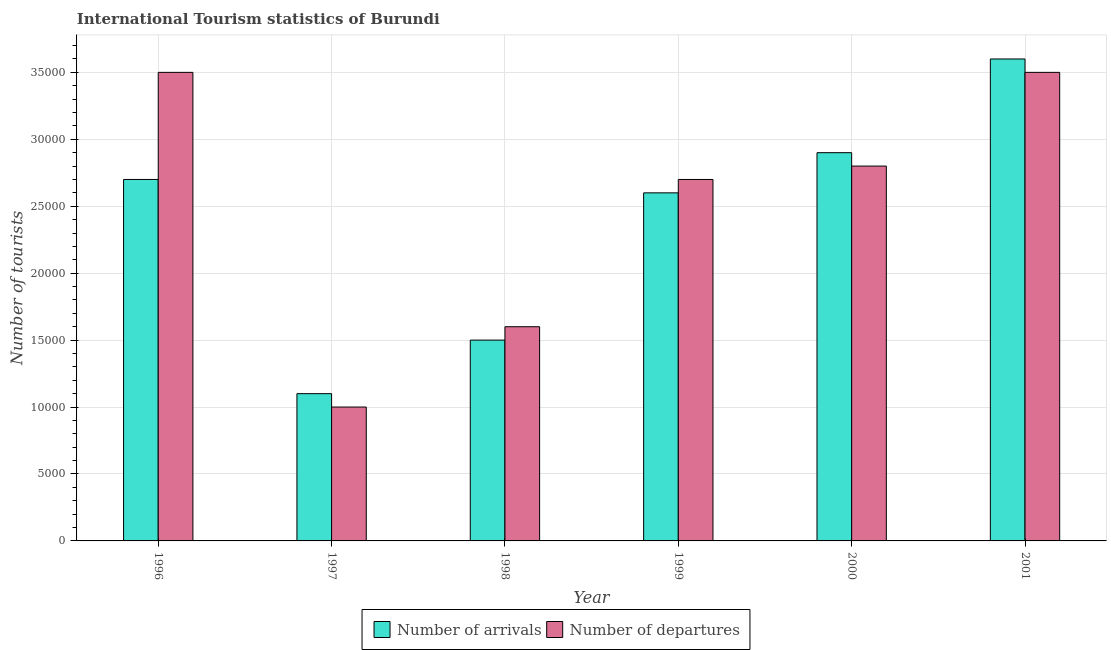How many bars are there on the 6th tick from the right?
Give a very brief answer. 2. What is the label of the 1st group of bars from the left?
Your answer should be very brief. 1996. What is the number of tourist departures in 1998?
Provide a short and direct response. 1.60e+04. Across all years, what is the maximum number of tourist departures?
Provide a short and direct response. 3.50e+04. Across all years, what is the minimum number of tourist arrivals?
Offer a terse response. 1.10e+04. In which year was the number of tourist departures minimum?
Ensure brevity in your answer.  1997. What is the total number of tourist departures in the graph?
Your answer should be very brief. 1.51e+05. What is the difference between the number of tourist departures in 1999 and that in 2001?
Keep it short and to the point. -8000. What is the difference between the number of tourist departures in 2000 and the number of tourist arrivals in 1997?
Provide a short and direct response. 1.80e+04. What is the average number of tourist arrivals per year?
Your response must be concise. 2.40e+04. Is the number of tourist departures in 1998 less than that in 1999?
Offer a very short reply. Yes. What is the difference between the highest and the second highest number of tourist arrivals?
Make the answer very short. 7000. What is the difference between the highest and the lowest number of tourist arrivals?
Your answer should be very brief. 2.50e+04. In how many years, is the number of tourist departures greater than the average number of tourist departures taken over all years?
Your response must be concise. 4. What does the 2nd bar from the left in 1999 represents?
Offer a very short reply. Number of departures. What does the 1st bar from the right in 1998 represents?
Your response must be concise. Number of departures. What is the difference between two consecutive major ticks on the Y-axis?
Provide a succinct answer. 5000. Are the values on the major ticks of Y-axis written in scientific E-notation?
Provide a succinct answer. No. Does the graph contain grids?
Your answer should be very brief. Yes. How many legend labels are there?
Keep it short and to the point. 2. What is the title of the graph?
Offer a terse response. International Tourism statistics of Burundi. Does "Domestic Liabilities" appear as one of the legend labels in the graph?
Your answer should be very brief. No. What is the label or title of the X-axis?
Provide a short and direct response. Year. What is the label or title of the Y-axis?
Offer a very short reply. Number of tourists. What is the Number of tourists in Number of arrivals in 1996?
Make the answer very short. 2.70e+04. What is the Number of tourists in Number of departures in 1996?
Your answer should be very brief. 3.50e+04. What is the Number of tourists in Number of arrivals in 1997?
Provide a succinct answer. 1.10e+04. What is the Number of tourists of Number of departures in 1997?
Make the answer very short. 10000. What is the Number of tourists of Number of arrivals in 1998?
Your response must be concise. 1.50e+04. What is the Number of tourists of Number of departures in 1998?
Give a very brief answer. 1.60e+04. What is the Number of tourists in Number of arrivals in 1999?
Provide a short and direct response. 2.60e+04. What is the Number of tourists in Number of departures in 1999?
Provide a short and direct response. 2.70e+04. What is the Number of tourists of Number of arrivals in 2000?
Provide a short and direct response. 2.90e+04. What is the Number of tourists of Number of departures in 2000?
Provide a short and direct response. 2.80e+04. What is the Number of tourists of Number of arrivals in 2001?
Give a very brief answer. 3.60e+04. What is the Number of tourists in Number of departures in 2001?
Your answer should be compact. 3.50e+04. Across all years, what is the maximum Number of tourists of Number of arrivals?
Keep it short and to the point. 3.60e+04. Across all years, what is the maximum Number of tourists in Number of departures?
Keep it short and to the point. 3.50e+04. Across all years, what is the minimum Number of tourists of Number of arrivals?
Your answer should be very brief. 1.10e+04. What is the total Number of tourists of Number of arrivals in the graph?
Your answer should be compact. 1.44e+05. What is the total Number of tourists in Number of departures in the graph?
Provide a succinct answer. 1.51e+05. What is the difference between the Number of tourists of Number of arrivals in 1996 and that in 1997?
Give a very brief answer. 1.60e+04. What is the difference between the Number of tourists in Number of departures in 1996 and that in 1997?
Make the answer very short. 2.50e+04. What is the difference between the Number of tourists of Number of arrivals in 1996 and that in 1998?
Provide a succinct answer. 1.20e+04. What is the difference between the Number of tourists in Number of departures in 1996 and that in 1998?
Offer a terse response. 1.90e+04. What is the difference between the Number of tourists of Number of arrivals in 1996 and that in 1999?
Provide a succinct answer. 1000. What is the difference between the Number of tourists in Number of departures in 1996 and that in 1999?
Give a very brief answer. 8000. What is the difference between the Number of tourists of Number of arrivals in 1996 and that in 2000?
Your response must be concise. -2000. What is the difference between the Number of tourists in Number of departures in 1996 and that in 2000?
Provide a short and direct response. 7000. What is the difference between the Number of tourists in Number of arrivals in 1996 and that in 2001?
Give a very brief answer. -9000. What is the difference between the Number of tourists of Number of departures in 1996 and that in 2001?
Your response must be concise. 0. What is the difference between the Number of tourists of Number of arrivals in 1997 and that in 1998?
Offer a very short reply. -4000. What is the difference between the Number of tourists in Number of departures in 1997 and that in 1998?
Offer a terse response. -6000. What is the difference between the Number of tourists of Number of arrivals in 1997 and that in 1999?
Offer a very short reply. -1.50e+04. What is the difference between the Number of tourists in Number of departures in 1997 and that in 1999?
Your answer should be compact. -1.70e+04. What is the difference between the Number of tourists of Number of arrivals in 1997 and that in 2000?
Ensure brevity in your answer.  -1.80e+04. What is the difference between the Number of tourists in Number of departures in 1997 and that in 2000?
Make the answer very short. -1.80e+04. What is the difference between the Number of tourists of Number of arrivals in 1997 and that in 2001?
Keep it short and to the point. -2.50e+04. What is the difference between the Number of tourists in Number of departures in 1997 and that in 2001?
Provide a succinct answer. -2.50e+04. What is the difference between the Number of tourists of Number of arrivals in 1998 and that in 1999?
Your answer should be compact. -1.10e+04. What is the difference between the Number of tourists of Number of departures in 1998 and that in 1999?
Offer a terse response. -1.10e+04. What is the difference between the Number of tourists of Number of arrivals in 1998 and that in 2000?
Offer a terse response. -1.40e+04. What is the difference between the Number of tourists in Number of departures in 1998 and that in 2000?
Provide a succinct answer. -1.20e+04. What is the difference between the Number of tourists in Number of arrivals in 1998 and that in 2001?
Make the answer very short. -2.10e+04. What is the difference between the Number of tourists of Number of departures in 1998 and that in 2001?
Your answer should be compact. -1.90e+04. What is the difference between the Number of tourists of Number of arrivals in 1999 and that in 2000?
Give a very brief answer. -3000. What is the difference between the Number of tourists of Number of departures in 1999 and that in 2000?
Provide a short and direct response. -1000. What is the difference between the Number of tourists of Number of arrivals in 1999 and that in 2001?
Your answer should be compact. -10000. What is the difference between the Number of tourists in Number of departures in 1999 and that in 2001?
Offer a terse response. -8000. What is the difference between the Number of tourists of Number of arrivals in 2000 and that in 2001?
Ensure brevity in your answer.  -7000. What is the difference between the Number of tourists in Number of departures in 2000 and that in 2001?
Your answer should be compact. -7000. What is the difference between the Number of tourists in Number of arrivals in 1996 and the Number of tourists in Number of departures in 1997?
Offer a very short reply. 1.70e+04. What is the difference between the Number of tourists of Number of arrivals in 1996 and the Number of tourists of Number of departures in 1998?
Ensure brevity in your answer.  1.10e+04. What is the difference between the Number of tourists in Number of arrivals in 1996 and the Number of tourists in Number of departures in 1999?
Keep it short and to the point. 0. What is the difference between the Number of tourists in Number of arrivals in 1996 and the Number of tourists in Number of departures in 2000?
Offer a terse response. -1000. What is the difference between the Number of tourists in Number of arrivals in 1996 and the Number of tourists in Number of departures in 2001?
Offer a terse response. -8000. What is the difference between the Number of tourists of Number of arrivals in 1997 and the Number of tourists of Number of departures in 1998?
Make the answer very short. -5000. What is the difference between the Number of tourists in Number of arrivals in 1997 and the Number of tourists in Number of departures in 1999?
Your answer should be compact. -1.60e+04. What is the difference between the Number of tourists of Number of arrivals in 1997 and the Number of tourists of Number of departures in 2000?
Ensure brevity in your answer.  -1.70e+04. What is the difference between the Number of tourists of Number of arrivals in 1997 and the Number of tourists of Number of departures in 2001?
Offer a terse response. -2.40e+04. What is the difference between the Number of tourists in Number of arrivals in 1998 and the Number of tourists in Number of departures in 1999?
Your answer should be compact. -1.20e+04. What is the difference between the Number of tourists of Number of arrivals in 1998 and the Number of tourists of Number of departures in 2000?
Make the answer very short. -1.30e+04. What is the difference between the Number of tourists of Number of arrivals in 1999 and the Number of tourists of Number of departures in 2000?
Offer a very short reply. -2000. What is the difference between the Number of tourists of Number of arrivals in 1999 and the Number of tourists of Number of departures in 2001?
Keep it short and to the point. -9000. What is the difference between the Number of tourists in Number of arrivals in 2000 and the Number of tourists in Number of departures in 2001?
Offer a very short reply. -6000. What is the average Number of tourists in Number of arrivals per year?
Ensure brevity in your answer.  2.40e+04. What is the average Number of tourists in Number of departures per year?
Provide a succinct answer. 2.52e+04. In the year 1996, what is the difference between the Number of tourists in Number of arrivals and Number of tourists in Number of departures?
Provide a succinct answer. -8000. In the year 1997, what is the difference between the Number of tourists in Number of arrivals and Number of tourists in Number of departures?
Offer a terse response. 1000. In the year 1998, what is the difference between the Number of tourists of Number of arrivals and Number of tourists of Number of departures?
Keep it short and to the point. -1000. In the year 1999, what is the difference between the Number of tourists of Number of arrivals and Number of tourists of Number of departures?
Offer a very short reply. -1000. What is the ratio of the Number of tourists in Number of arrivals in 1996 to that in 1997?
Provide a succinct answer. 2.45. What is the ratio of the Number of tourists of Number of departures in 1996 to that in 1997?
Give a very brief answer. 3.5. What is the ratio of the Number of tourists in Number of departures in 1996 to that in 1998?
Your answer should be compact. 2.19. What is the ratio of the Number of tourists in Number of departures in 1996 to that in 1999?
Your answer should be compact. 1.3. What is the ratio of the Number of tourists of Number of arrivals in 1996 to that in 2000?
Ensure brevity in your answer.  0.93. What is the ratio of the Number of tourists in Number of departures in 1996 to that in 2000?
Offer a very short reply. 1.25. What is the ratio of the Number of tourists in Number of departures in 1996 to that in 2001?
Offer a terse response. 1. What is the ratio of the Number of tourists of Number of arrivals in 1997 to that in 1998?
Your answer should be compact. 0.73. What is the ratio of the Number of tourists in Number of departures in 1997 to that in 1998?
Make the answer very short. 0.62. What is the ratio of the Number of tourists in Number of arrivals in 1997 to that in 1999?
Make the answer very short. 0.42. What is the ratio of the Number of tourists of Number of departures in 1997 to that in 1999?
Give a very brief answer. 0.37. What is the ratio of the Number of tourists in Number of arrivals in 1997 to that in 2000?
Provide a succinct answer. 0.38. What is the ratio of the Number of tourists of Number of departures in 1997 to that in 2000?
Offer a terse response. 0.36. What is the ratio of the Number of tourists of Number of arrivals in 1997 to that in 2001?
Give a very brief answer. 0.31. What is the ratio of the Number of tourists of Number of departures in 1997 to that in 2001?
Your answer should be very brief. 0.29. What is the ratio of the Number of tourists of Number of arrivals in 1998 to that in 1999?
Provide a succinct answer. 0.58. What is the ratio of the Number of tourists in Number of departures in 1998 to that in 1999?
Ensure brevity in your answer.  0.59. What is the ratio of the Number of tourists in Number of arrivals in 1998 to that in 2000?
Provide a succinct answer. 0.52. What is the ratio of the Number of tourists of Number of arrivals in 1998 to that in 2001?
Give a very brief answer. 0.42. What is the ratio of the Number of tourists in Number of departures in 1998 to that in 2001?
Make the answer very short. 0.46. What is the ratio of the Number of tourists of Number of arrivals in 1999 to that in 2000?
Your answer should be compact. 0.9. What is the ratio of the Number of tourists of Number of departures in 1999 to that in 2000?
Give a very brief answer. 0.96. What is the ratio of the Number of tourists of Number of arrivals in 1999 to that in 2001?
Keep it short and to the point. 0.72. What is the ratio of the Number of tourists of Number of departures in 1999 to that in 2001?
Your answer should be compact. 0.77. What is the ratio of the Number of tourists in Number of arrivals in 2000 to that in 2001?
Ensure brevity in your answer.  0.81. What is the difference between the highest and the second highest Number of tourists of Number of arrivals?
Provide a succinct answer. 7000. What is the difference between the highest and the lowest Number of tourists of Number of arrivals?
Offer a very short reply. 2.50e+04. What is the difference between the highest and the lowest Number of tourists of Number of departures?
Give a very brief answer. 2.50e+04. 